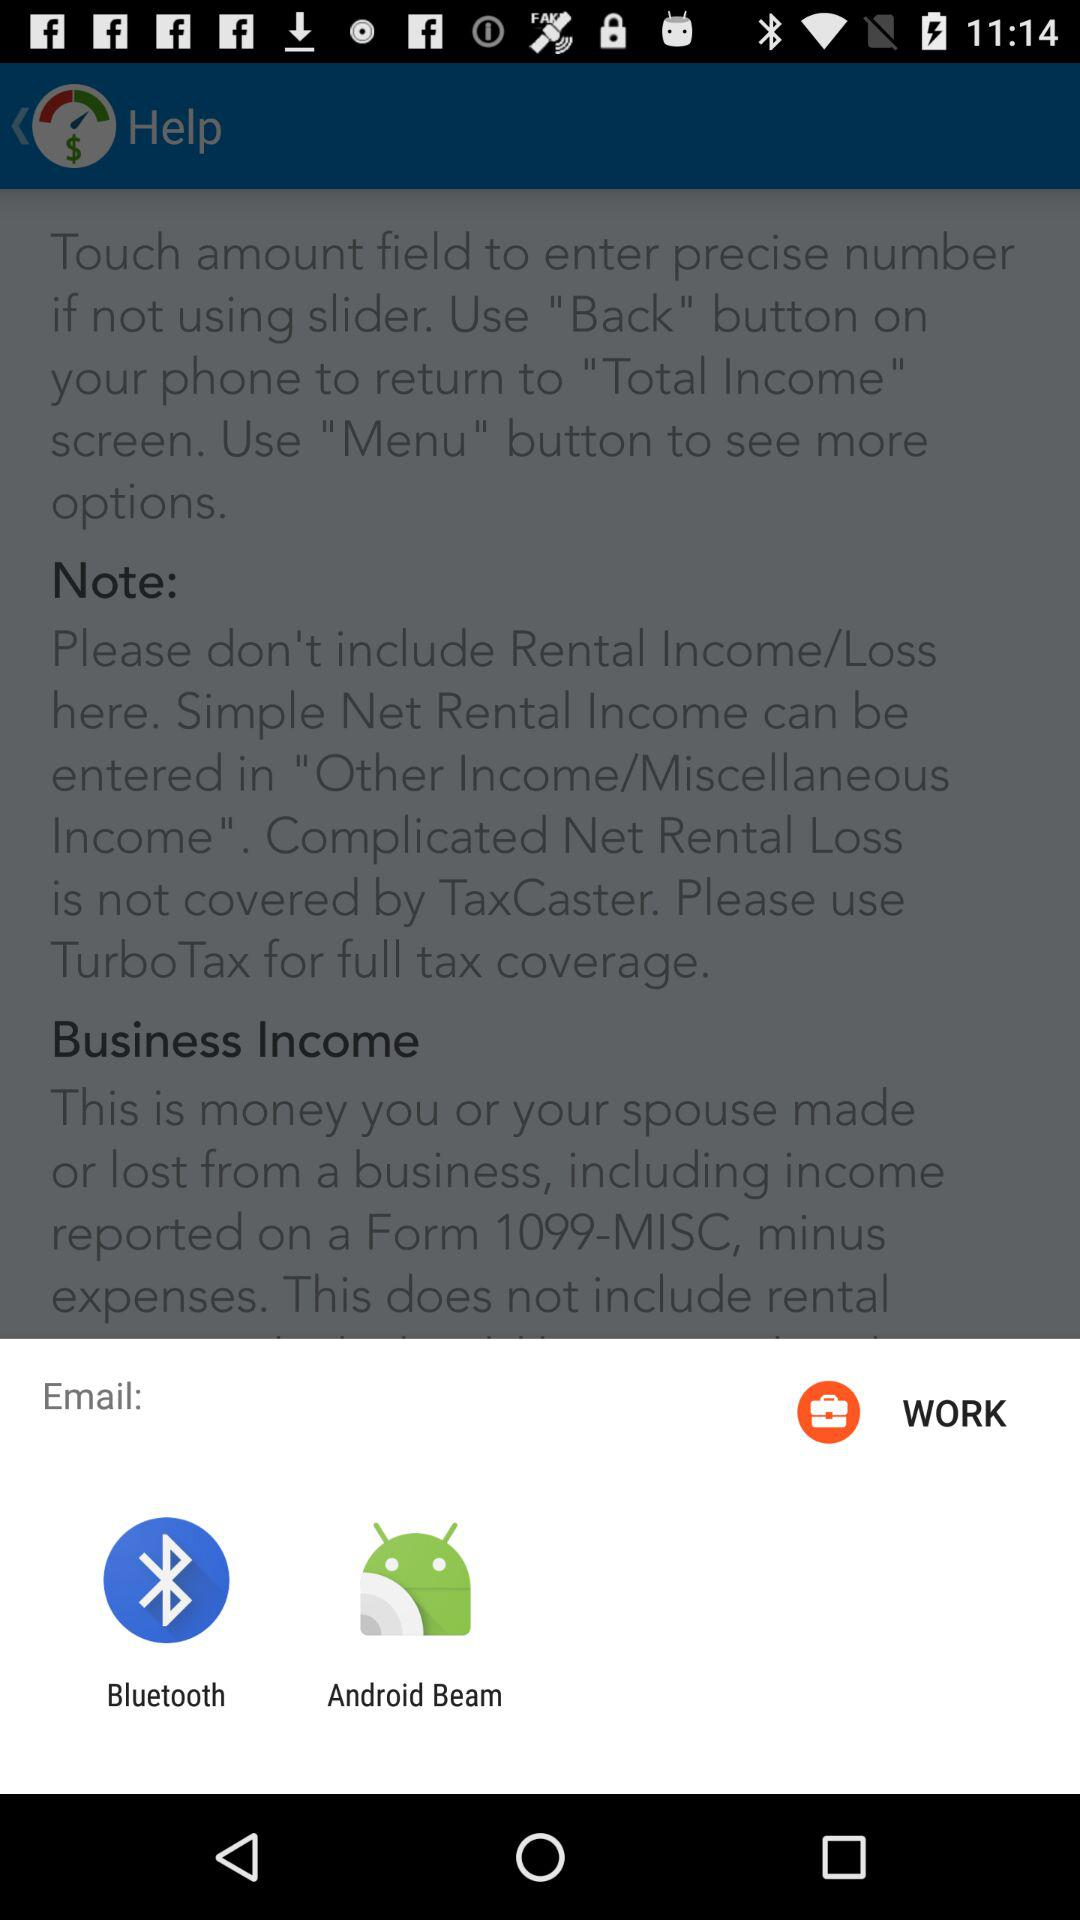What are the different options for email? The different options for email are "Bluetooth" and "Android Beam". 